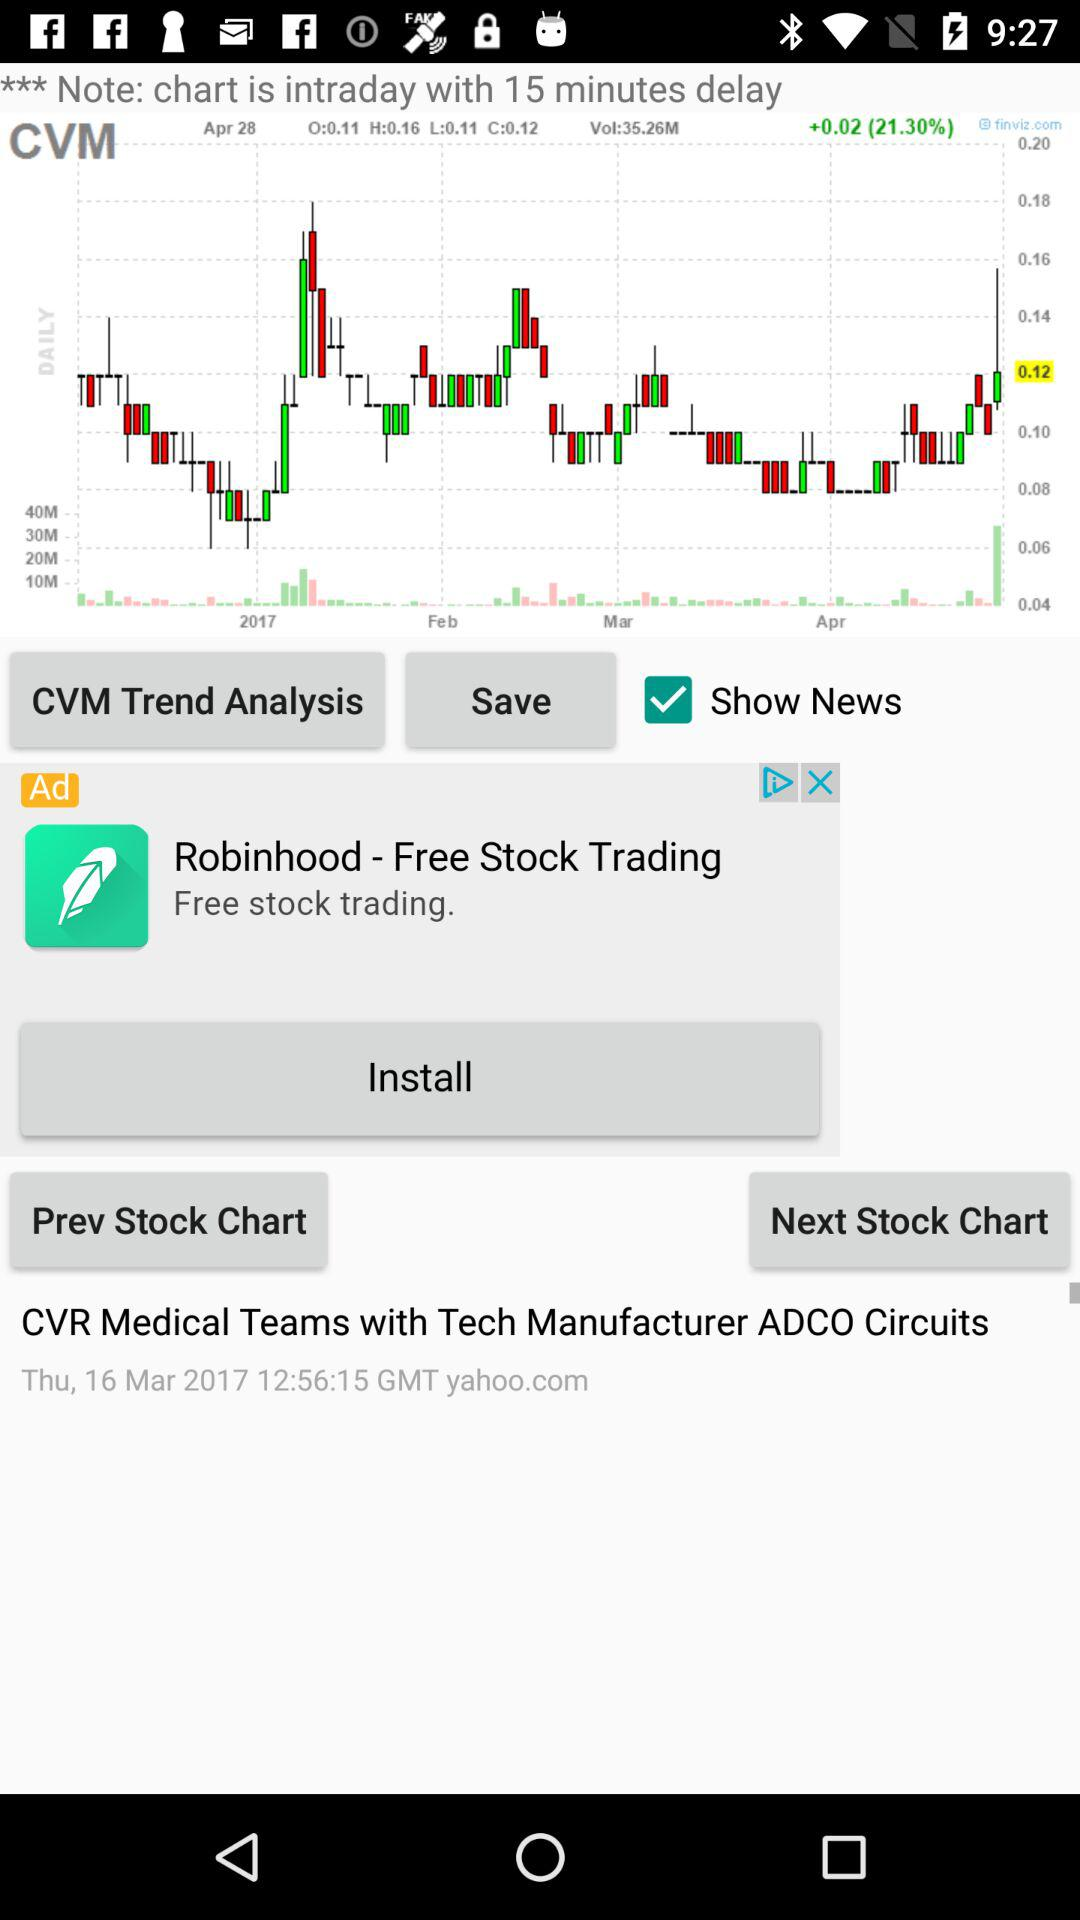What is on the next stock chart?
When the provided information is insufficient, respond with <no answer>. <no answer> 